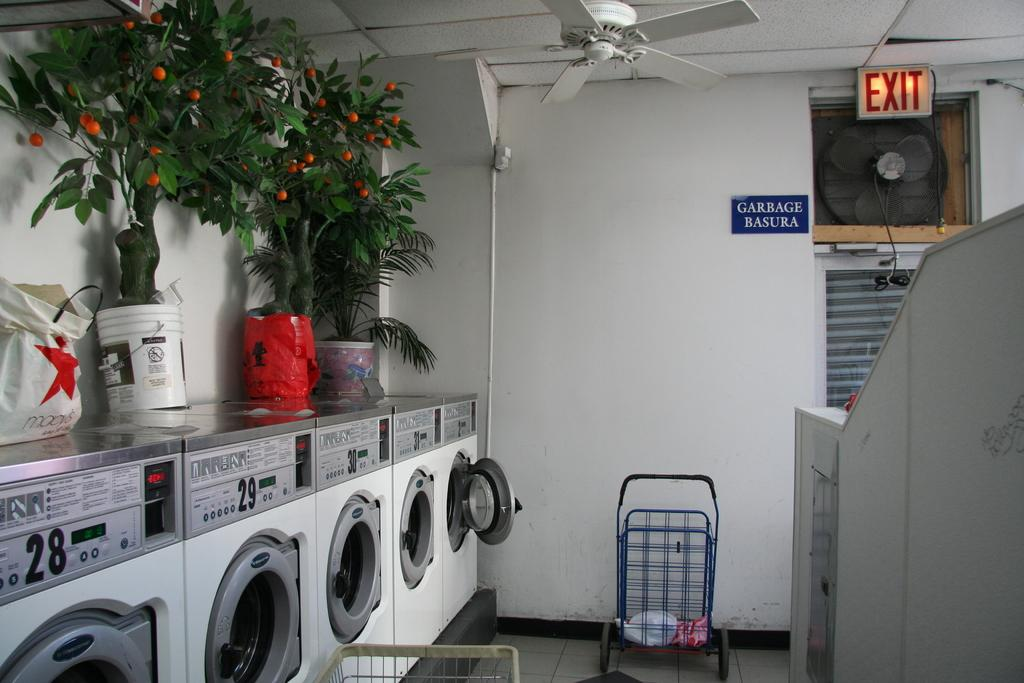<image>
Present a compact description of the photo's key features. A laundromat with a sign for garbage just under the exit sign. 